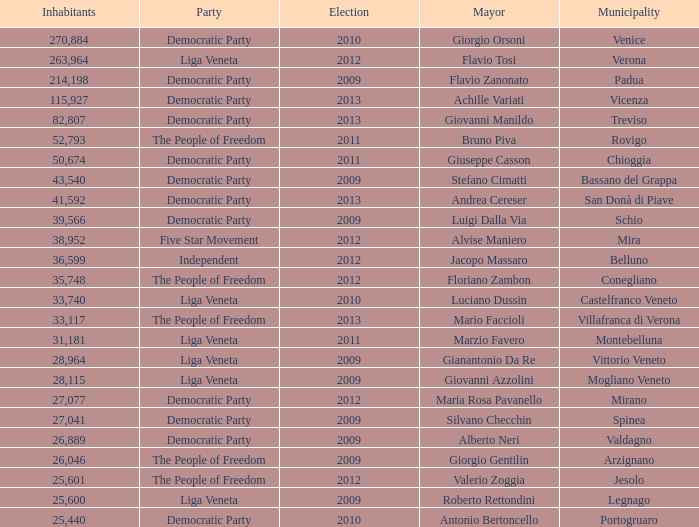How many members were in the democratic party during a mayoral election prior to 2009 for stefano cimatti? 0.0. 